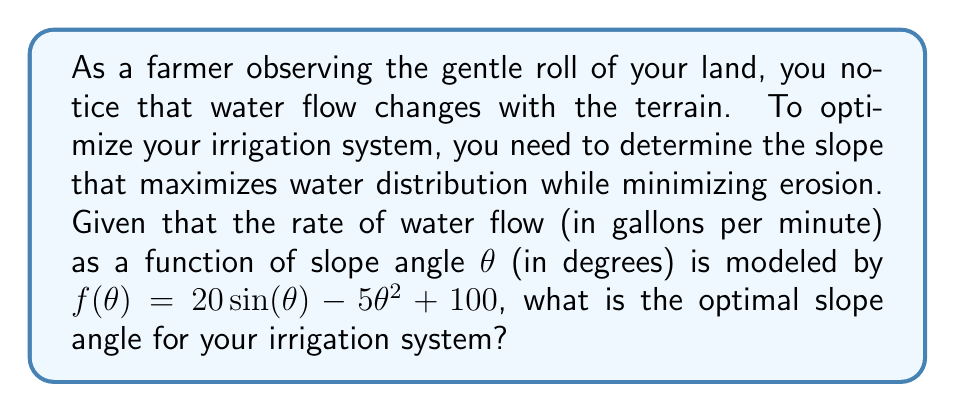Help me with this question. To find the optimal slope angle, we need to determine the maximum point of the function $f(\theta)$. This can be done by finding where the derivative of $f(\theta)$ equals zero.

Step 1: Find the derivative of $f(\theta)$
$$f'(\theta) = 20\cos(\theta) - 10\theta$$

Step 2: Set the derivative equal to zero and solve for $\theta$
$$20\cos(\theta) - 10\theta = 0$$
$$2\cos(\theta) = \theta$$

This equation cannot be solved algebraically, so we need to use numerical methods or graphical analysis.

Step 3: Use a graphing calculator or computer software to plot $y = 2\cos(\theta)$ and $y = \theta$. The intersection point gives the solution.

Step 4: The solution is approximately $\theta \approx 1.1653$ radians.

Step 5: Convert radians to degrees
$$\theta \approx 1.1653 \times \frac{180}{\pi} \approx 66.76°$$

Therefore, the optimal slope angle for the irrigation system is approximately 66.76 degrees.
Answer: 66.76° 